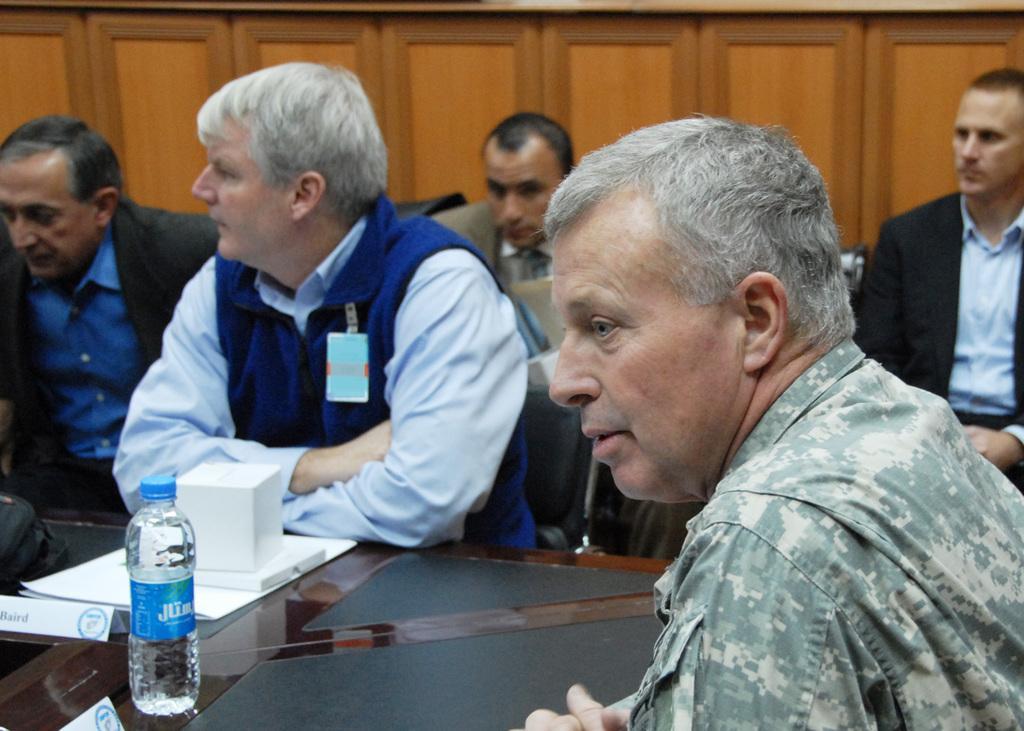Please provide a concise description of this image. In this image there are a few people seated on chairs, in front of them there is a table, on top of the table there is a bottle of water and papers, behind them there are two other persons seated on chairs. 